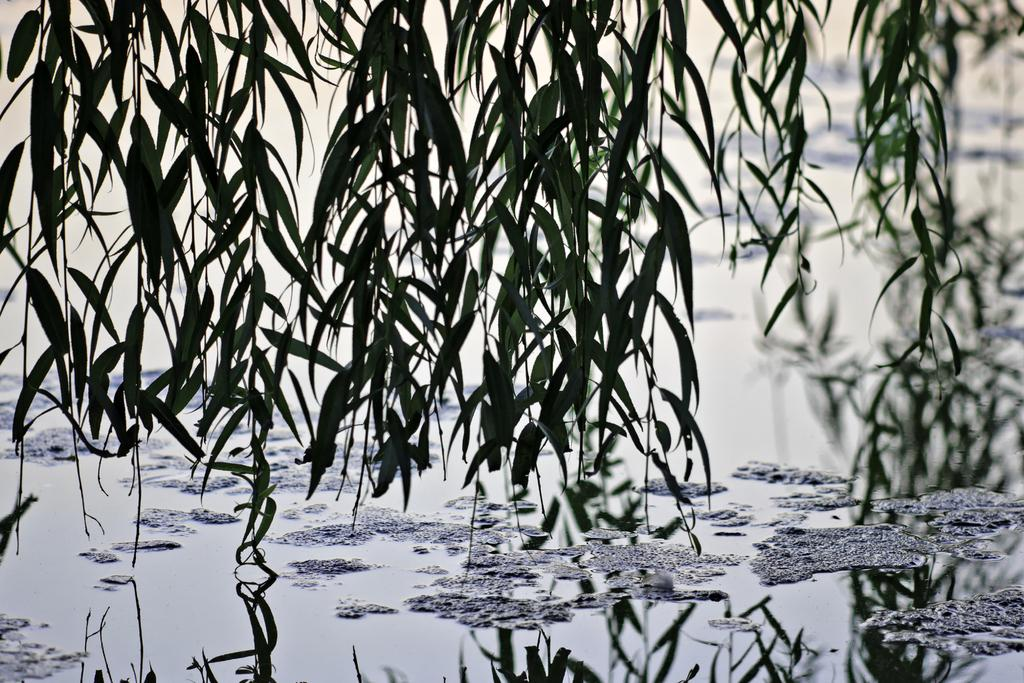What type of living organisms can be seen in the image? Plants can be seen in the image. What is visible in the image besides the plants? Water is visible in the image. How would you describe the background of the image? The background of the image is blurred. What type of acoustics can be heard from the pot in the image? There is no pot present in the image, and therefore no acoustics can be heard from it. 